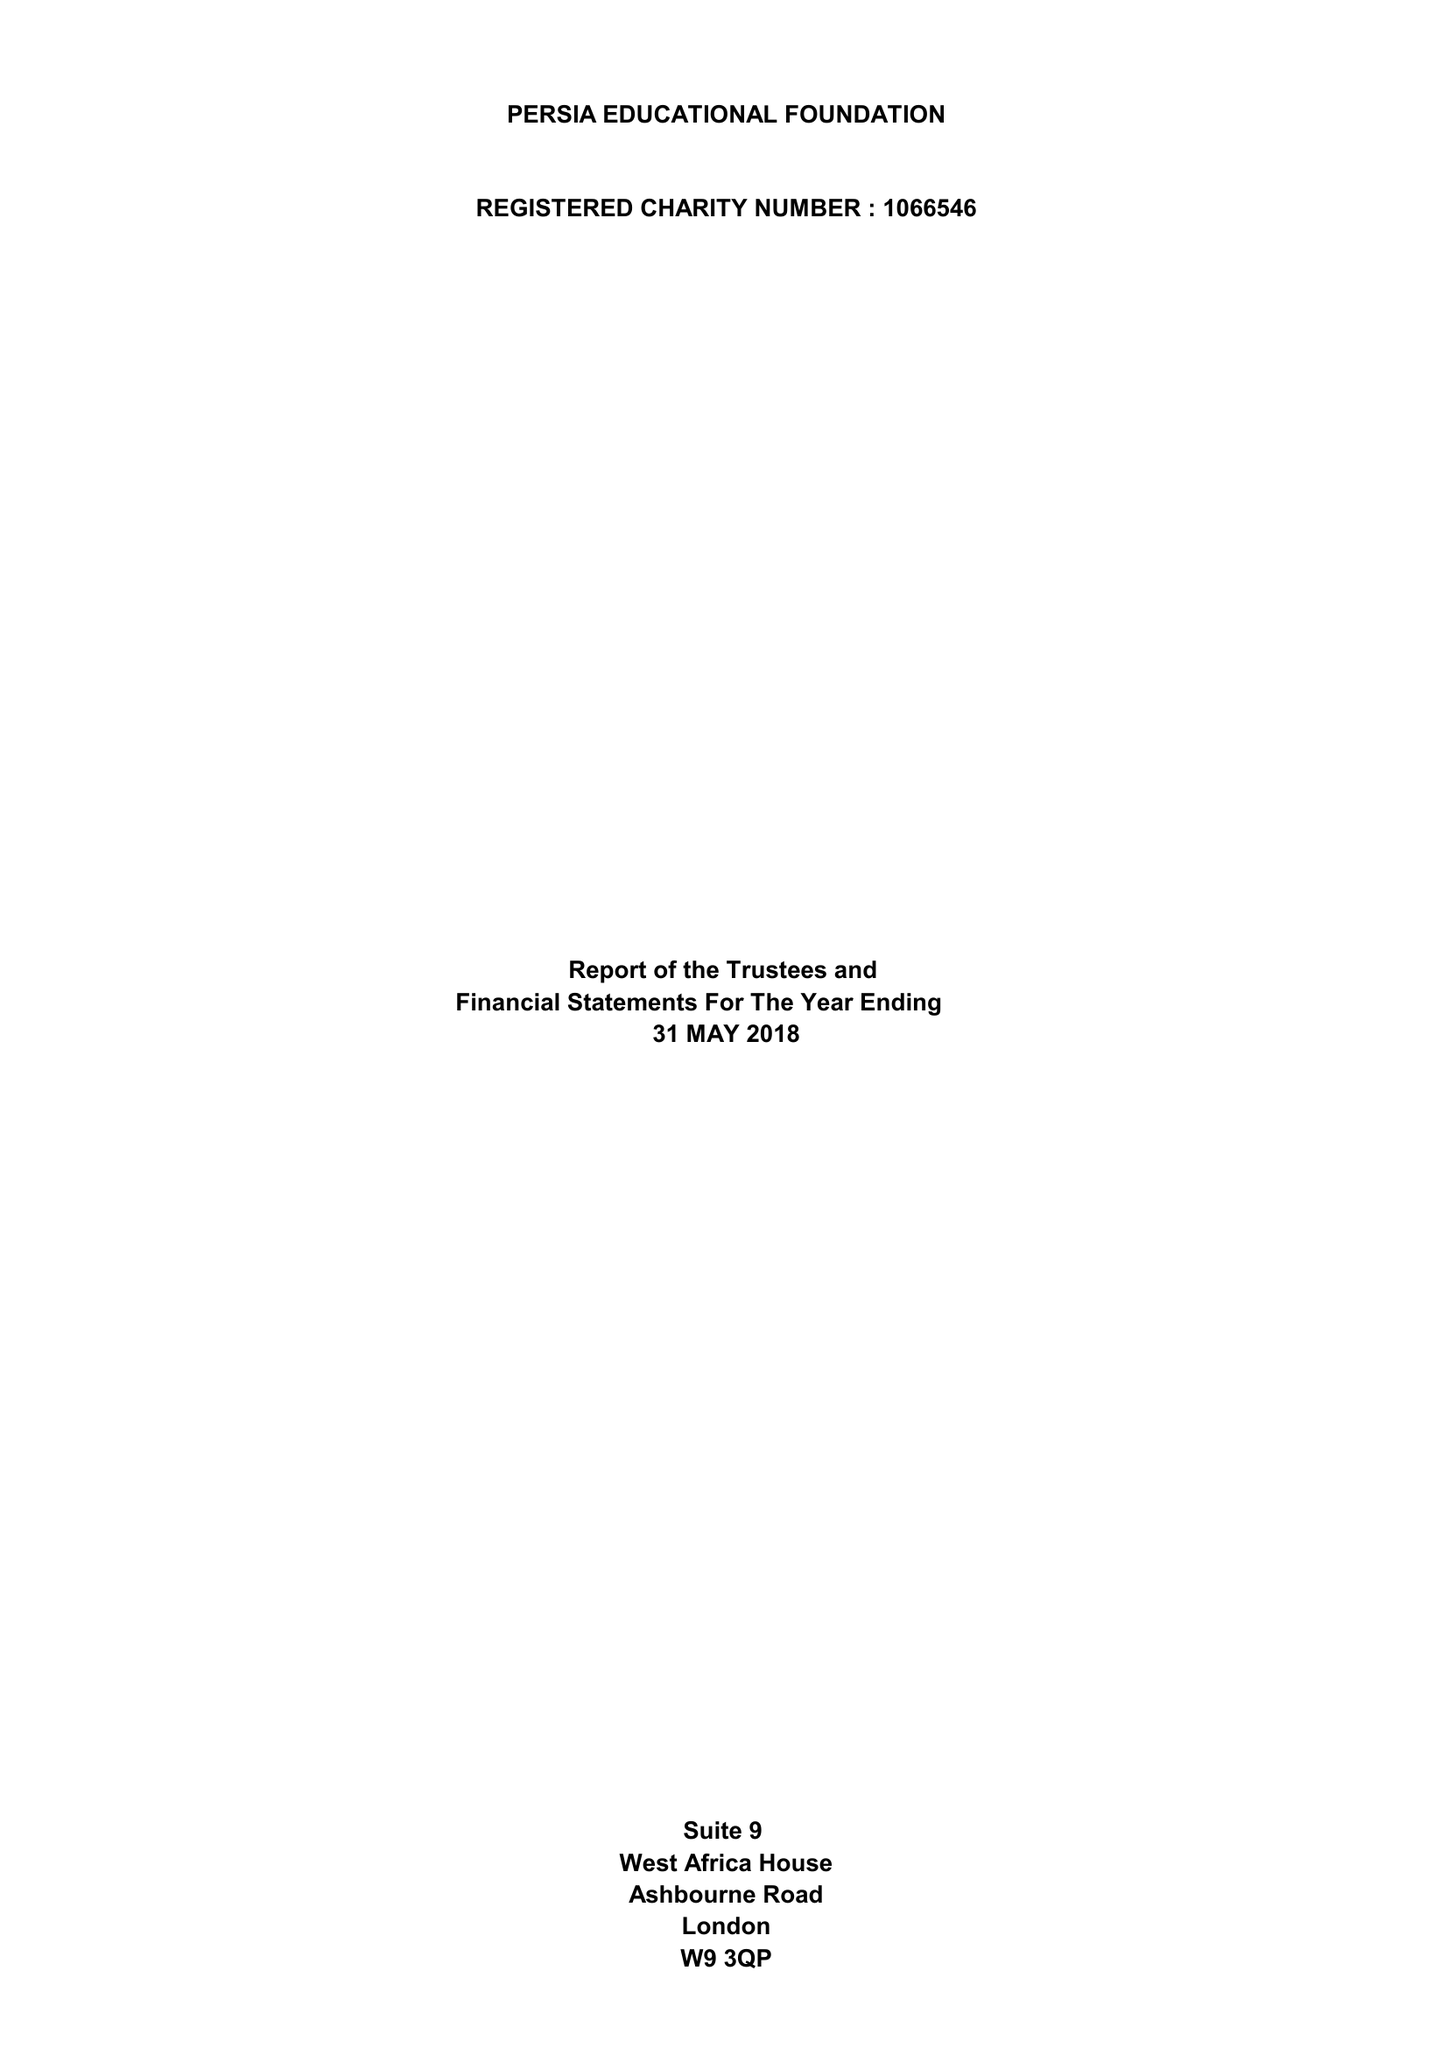What is the value for the address__postcode?
Answer the question using a single word or phrase. W9 3QP 